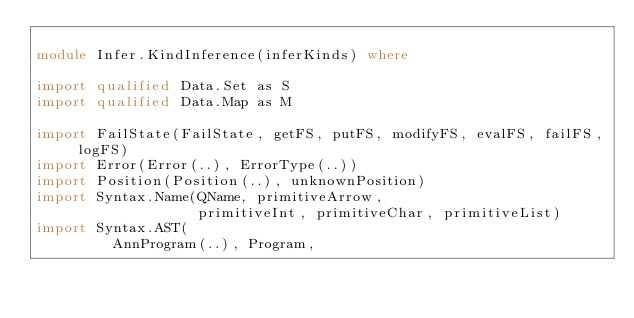<code> <loc_0><loc_0><loc_500><loc_500><_Haskell_>
module Infer.KindInference(inferKinds) where

import qualified Data.Set as S
import qualified Data.Map as M

import FailState(FailState, getFS, putFS, modifyFS, evalFS, failFS, logFS)
import Error(Error(..), ErrorType(..))
import Position(Position(..), unknownPosition)
import Syntax.Name(QName, primitiveArrow,
                   primitiveInt, primitiveChar, primitiveList)
import Syntax.AST(
         AnnProgram(..), Program,</code> 